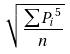Convert formula to latex. <formula><loc_0><loc_0><loc_500><loc_500>\sqrt { \frac { \sum { P _ { i } } ^ { 5 } } { n } }</formula> 